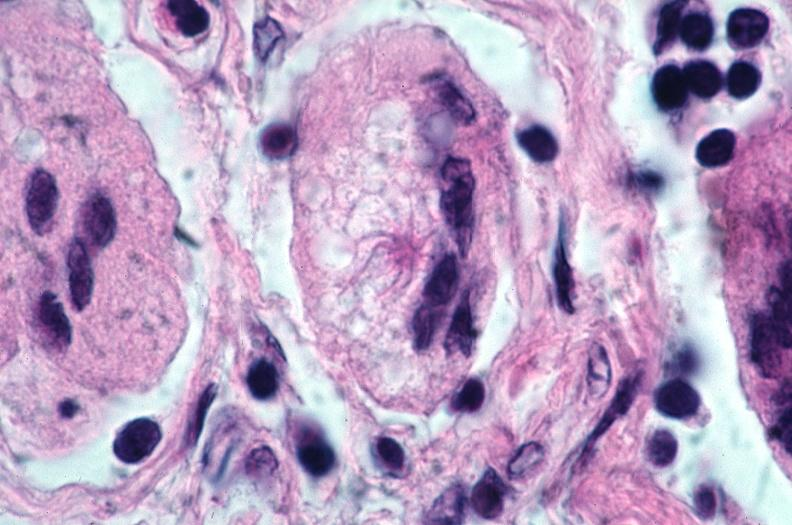s respiratory present?
Answer the question using a single word or phrase. Yes 